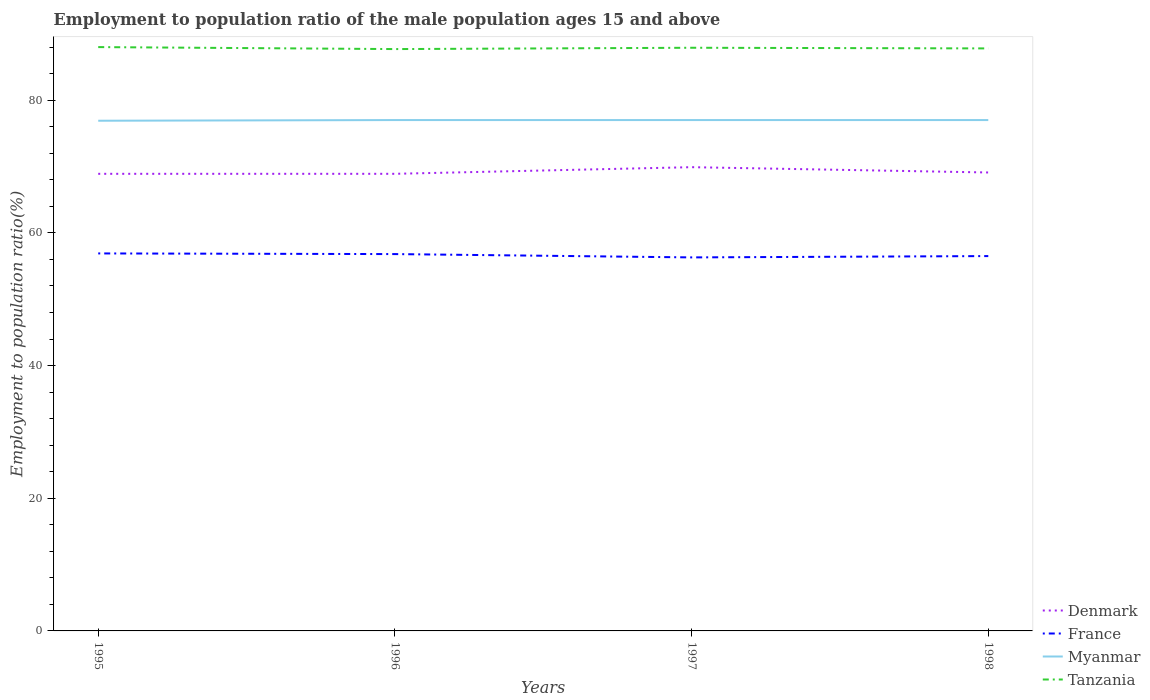How many different coloured lines are there?
Provide a succinct answer. 4. Does the line corresponding to Myanmar intersect with the line corresponding to France?
Offer a very short reply. No. Is the number of lines equal to the number of legend labels?
Give a very brief answer. Yes. Across all years, what is the maximum employment to population ratio in France?
Keep it short and to the point. 56.3. What is the difference between the highest and the second highest employment to population ratio in Tanzania?
Ensure brevity in your answer.  0.3. What is the difference between the highest and the lowest employment to population ratio in Denmark?
Offer a very short reply. 1. How many lines are there?
Provide a short and direct response. 4. What is the difference between two consecutive major ticks on the Y-axis?
Offer a very short reply. 20. Are the values on the major ticks of Y-axis written in scientific E-notation?
Offer a terse response. No. What is the title of the graph?
Your response must be concise. Employment to population ratio of the male population ages 15 and above. Does "Trinidad and Tobago" appear as one of the legend labels in the graph?
Your answer should be very brief. No. What is the label or title of the X-axis?
Your answer should be very brief. Years. What is the Employment to population ratio(%) of Denmark in 1995?
Give a very brief answer. 68.9. What is the Employment to population ratio(%) of France in 1995?
Ensure brevity in your answer.  56.9. What is the Employment to population ratio(%) of Myanmar in 1995?
Give a very brief answer. 76.9. What is the Employment to population ratio(%) in Tanzania in 1995?
Provide a succinct answer. 88. What is the Employment to population ratio(%) of Denmark in 1996?
Offer a terse response. 68.9. What is the Employment to population ratio(%) in France in 1996?
Your response must be concise. 56.8. What is the Employment to population ratio(%) in Tanzania in 1996?
Your answer should be compact. 87.7. What is the Employment to population ratio(%) of Denmark in 1997?
Your answer should be compact. 69.9. What is the Employment to population ratio(%) in France in 1997?
Your answer should be compact. 56.3. What is the Employment to population ratio(%) of Tanzania in 1997?
Ensure brevity in your answer.  87.9. What is the Employment to population ratio(%) in Denmark in 1998?
Your answer should be very brief. 69.1. What is the Employment to population ratio(%) of France in 1998?
Offer a very short reply. 56.5. What is the Employment to population ratio(%) of Myanmar in 1998?
Your answer should be very brief. 77. What is the Employment to population ratio(%) of Tanzania in 1998?
Your answer should be very brief. 87.8. Across all years, what is the maximum Employment to population ratio(%) in Denmark?
Provide a short and direct response. 69.9. Across all years, what is the maximum Employment to population ratio(%) in France?
Give a very brief answer. 56.9. Across all years, what is the maximum Employment to population ratio(%) in Myanmar?
Your answer should be very brief. 77. Across all years, what is the maximum Employment to population ratio(%) of Tanzania?
Offer a terse response. 88. Across all years, what is the minimum Employment to population ratio(%) of Denmark?
Offer a very short reply. 68.9. Across all years, what is the minimum Employment to population ratio(%) of France?
Make the answer very short. 56.3. Across all years, what is the minimum Employment to population ratio(%) of Myanmar?
Give a very brief answer. 76.9. Across all years, what is the minimum Employment to population ratio(%) of Tanzania?
Your response must be concise. 87.7. What is the total Employment to population ratio(%) of Denmark in the graph?
Provide a short and direct response. 276.8. What is the total Employment to population ratio(%) in France in the graph?
Your response must be concise. 226.5. What is the total Employment to population ratio(%) in Myanmar in the graph?
Give a very brief answer. 307.9. What is the total Employment to population ratio(%) of Tanzania in the graph?
Your answer should be very brief. 351.4. What is the difference between the Employment to population ratio(%) of France in 1995 and that in 1996?
Keep it short and to the point. 0.1. What is the difference between the Employment to population ratio(%) of Myanmar in 1995 and that in 1996?
Your answer should be very brief. -0.1. What is the difference between the Employment to population ratio(%) of Tanzania in 1995 and that in 1996?
Offer a very short reply. 0.3. What is the difference between the Employment to population ratio(%) of France in 1995 and that in 1997?
Offer a very short reply. 0.6. What is the difference between the Employment to population ratio(%) in Tanzania in 1995 and that in 1997?
Provide a succinct answer. 0.1. What is the difference between the Employment to population ratio(%) of France in 1995 and that in 1998?
Provide a succinct answer. 0.4. What is the difference between the Employment to population ratio(%) of Tanzania in 1995 and that in 1998?
Your response must be concise. 0.2. What is the difference between the Employment to population ratio(%) of Denmark in 1996 and that in 1998?
Offer a very short reply. -0.2. What is the difference between the Employment to population ratio(%) in France in 1996 and that in 1998?
Offer a terse response. 0.3. What is the difference between the Employment to population ratio(%) of Tanzania in 1997 and that in 1998?
Offer a very short reply. 0.1. What is the difference between the Employment to population ratio(%) in Denmark in 1995 and the Employment to population ratio(%) in France in 1996?
Provide a short and direct response. 12.1. What is the difference between the Employment to population ratio(%) in Denmark in 1995 and the Employment to population ratio(%) in Tanzania in 1996?
Offer a terse response. -18.8. What is the difference between the Employment to population ratio(%) of France in 1995 and the Employment to population ratio(%) of Myanmar in 1996?
Your response must be concise. -20.1. What is the difference between the Employment to population ratio(%) in France in 1995 and the Employment to population ratio(%) in Tanzania in 1996?
Offer a terse response. -30.8. What is the difference between the Employment to population ratio(%) of Myanmar in 1995 and the Employment to population ratio(%) of Tanzania in 1996?
Offer a terse response. -10.8. What is the difference between the Employment to population ratio(%) of Denmark in 1995 and the Employment to population ratio(%) of France in 1997?
Offer a terse response. 12.6. What is the difference between the Employment to population ratio(%) in France in 1995 and the Employment to population ratio(%) in Myanmar in 1997?
Offer a terse response. -20.1. What is the difference between the Employment to population ratio(%) in France in 1995 and the Employment to population ratio(%) in Tanzania in 1997?
Your response must be concise. -31. What is the difference between the Employment to population ratio(%) of Myanmar in 1995 and the Employment to population ratio(%) of Tanzania in 1997?
Keep it short and to the point. -11. What is the difference between the Employment to population ratio(%) of Denmark in 1995 and the Employment to population ratio(%) of Tanzania in 1998?
Provide a short and direct response. -18.9. What is the difference between the Employment to population ratio(%) of France in 1995 and the Employment to population ratio(%) of Myanmar in 1998?
Provide a succinct answer. -20.1. What is the difference between the Employment to population ratio(%) of France in 1995 and the Employment to population ratio(%) of Tanzania in 1998?
Your answer should be very brief. -30.9. What is the difference between the Employment to population ratio(%) in France in 1996 and the Employment to population ratio(%) in Myanmar in 1997?
Your response must be concise. -20.2. What is the difference between the Employment to population ratio(%) of France in 1996 and the Employment to population ratio(%) of Tanzania in 1997?
Your answer should be compact. -31.1. What is the difference between the Employment to population ratio(%) in Denmark in 1996 and the Employment to population ratio(%) in France in 1998?
Offer a terse response. 12.4. What is the difference between the Employment to population ratio(%) of Denmark in 1996 and the Employment to population ratio(%) of Tanzania in 1998?
Provide a short and direct response. -18.9. What is the difference between the Employment to population ratio(%) in France in 1996 and the Employment to population ratio(%) in Myanmar in 1998?
Provide a succinct answer. -20.2. What is the difference between the Employment to population ratio(%) of France in 1996 and the Employment to population ratio(%) of Tanzania in 1998?
Your answer should be compact. -31. What is the difference between the Employment to population ratio(%) in Myanmar in 1996 and the Employment to population ratio(%) in Tanzania in 1998?
Provide a short and direct response. -10.8. What is the difference between the Employment to population ratio(%) in Denmark in 1997 and the Employment to population ratio(%) in Myanmar in 1998?
Your answer should be very brief. -7.1. What is the difference between the Employment to population ratio(%) of Denmark in 1997 and the Employment to population ratio(%) of Tanzania in 1998?
Keep it short and to the point. -17.9. What is the difference between the Employment to population ratio(%) of France in 1997 and the Employment to population ratio(%) of Myanmar in 1998?
Provide a short and direct response. -20.7. What is the difference between the Employment to population ratio(%) of France in 1997 and the Employment to population ratio(%) of Tanzania in 1998?
Keep it short and to the point. -31.5. What is the average Employment to population ratio(%) of Denmark per year?
Provide a short and direct response. 69.2. What is the average Employment to population ratio(%) in France per year?
Make the answer very short. 56.62. What is the average Employment to population ratio(%) in Myanmar per year?
Provide a short and direct response. 76.97. What is the average Employment to population ratio(%) of Tanzania per year?
Offer a terse response. 87.85. In the year 1995, what is the difference between the Employment to population ratio(%) of Denmark and Employment to population ratio(%) of France?
Provide a succinct answer. 12. In the year 1995, what is the difference between the Employment to population ratio(%) in Denmark and Employment to population ratio(%) in Myanmar?
Ensure brevity in your answer.  -8. In the year 1995, what is the difference between the Employment to population ratio(%) in Denmark and Employment to population ratio(%) in Tanzania?
Give a very brief answer. -19.1. In the year 1995, what is the difference between the Employment to population ratio(%) of France and Employment to population ratio(%) of Tanzania?
Keep it short and to the point. -31.1. In the year 1996, what is the difference between the Employment to population ratio(%) in Denmark and Employment to population ratio(%) in Myanmar?
Make the answer very short. -8.1. In the year 1996, what is the difference between the Employment to population ratio(%) in Denmark and Employment to population ratio(%) in Tanzania?
Offer a very short reply. -18.8. In the year 1996, what is the difference between the Employment to population ratio(%) of France and Employment to population ratio(%) of Myanmar?
Keep it short and to the point. -20.2. In the year 1996, what is the difference between the Employment to population ratio(%) in France and Employment to population ratio(%) in Tanzania?
Provide a succinct answer. -30.9. In the year 1997, what is the difference between the Employment to population ratio(%) in Denmark and Employment to population ratio(%) in France?
Your answer should be compact. 13.6. In the year 1997, what is the difference between the Employment to population ratio(%) of France and Employment to population ratio(%) of Myanmar?
Offer a very short reply. -20.7. In the year 1997, what is the difference between the Employment to population ratio(%) of France and Employment to population ratio(%) of Tanzania?
Provide a short and direct response. -31.6. In the year 1997, what is the difference between the Employment to population ratio(%) in Myanmar and Employment to population ratio(%) in Tanzania?
Keep it short and to the point. -10.9. In the year 1998, what is the difference between the Employment to population ratio(%) of Denmark and Employment to population ratio(%) of Myanmar?
Make the answer very short. -7.9. In the year 1998, what is the difference between the Employment to population ratio(%) in Denmark and Employment to population ratio(%) in Tanzania?
Your answer should be compact. -18.7. In the year 1998, what is the difference between the Employment to population ratio(%) of France and Employment to population ratio(%) of Myanmar?
Your response must be concise. -20.5. In the year 1998, what is the difference between the Employment to population ratio(%) in France and Employment to population ratio(%) in Tanzania?
Offer a terse response. -31.3. In the year 1998, what is the difference between the Employment to population ratio(%) of Myanmar and Employment to population ratio(%) of Tanzania?
Make the answer very short. -10.8. What is the ratio of the Employment to population ratio(%) in Myanmar in 1995 to that in 1996?
Your answer should be very brief. 1. What is the ratio of the Employment to population ratio(%) of Tanzania in 1995 to that in 1996?
Provide a short and direct response. 1. What is the ratio of the Employment to population ratio(%) of Denmark in 1995 to that in 1997?
Ensure brevity in your answer.  0.99. What is the ratio of the Employment to population ratio(%) in France in 1995 to that in 1997?
Give a very brief answer. 1.01. What is the ratio of the Employment to population ratio(%) of Myanmar in 1995 to that in 1997?
Offer a terse response. 1. What is the ratio of the Employment to population ratio(%) in Tanzania in 1995 to that in 1997?
Give a very brief answer. 1. What is the ratio of the Employment to population ratio(%) of France in 1995 to that in 1998?
Your response must be concise. 1.01. What is the ratio of the Employment to population ratio(%) in Denmark in 1996 to that in 1997?
Provide a succinct answer. 0.99. What is the ratio of the Employment to population ratio(%) in France in 1996 to that in 1997?
Offer a very short reply. 1.01. What is the ratio of the Employment to population ratio(%) of Myanmar in 1996 to that in 1997?
Ensure brevity in your answer.  1. What is the ratio of the Employment to population ratio(%) of Denmark in 1996 to that in 1998?
Ensure brevity in your answer.  1. What is the ratio of the Employment to population ratio(%) in France in 1996 to that in 1998?
Keep it short and to the point. 1.01. What is the ratio of the Employment to population ratio(%) of Myanmar in 1996 to that in 1998?
Give a very brief answer. 1. What is the ratio of the Employment to population ratio(%) of Denmark in 1997 to that in 1998?
Ensure brevity in your answer.  1.01. What is the ratio of the Employment to population ratio(%) of France in 1997 to that in 1998?
Provide a short and direct response. 1. What is the ratio of the Employment to population ratio(%) of Myanmar in 1997 to that in 1998?
Make the answer very short. 1. What is the ratio of the Employment to population ratio(%) in Tanzania in 1997 to that in 1998?
Your answer should be compact. 1. What is the difference between the highest and the second highest Employment to population ratio(%) of France?
Provide a succinct answer. 0.1. What is the difference between the highest and the second highest Employment to population ratio(%) of Tanzania?
Offer a very short reply. 0.1. What is the difference between the highest and the lowest Employment to population ratio(%) in Myanmar?
Provide a succinct answer. 0.1. What is the difference between the highest and the lowest Employment to population ratio(%) in Tanzania?
Give a very brief answer. 0.3. 